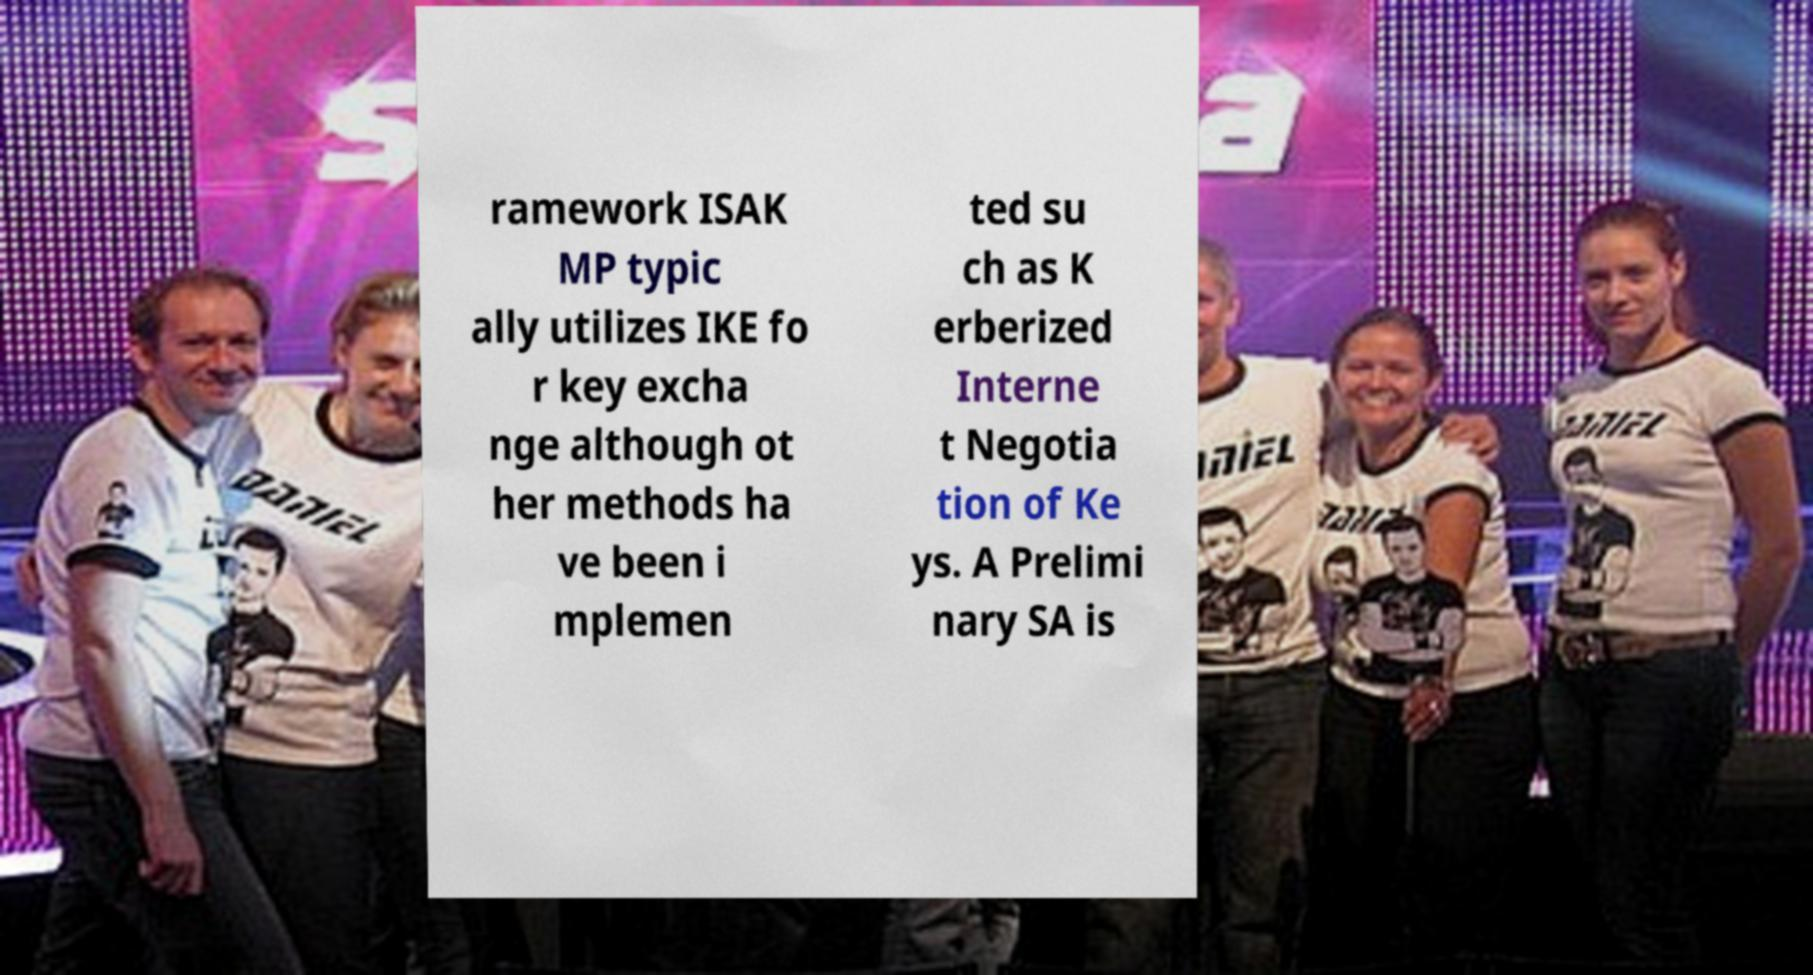Please read and relay the text visible in this image. What does it say? ramework ISAK MP typic ally utilizes IKE fo r key excha nge although ot her methods ha ve been i mplemen ted su ch as K erberized Interne t Negotia tion of Ke ys. A Prelimi nary SA is 